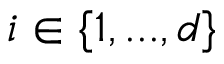<formula> <loc_0><loc_0><loc_500><loc_500>i \in \{ 1 , \dots , d \}</formula> 